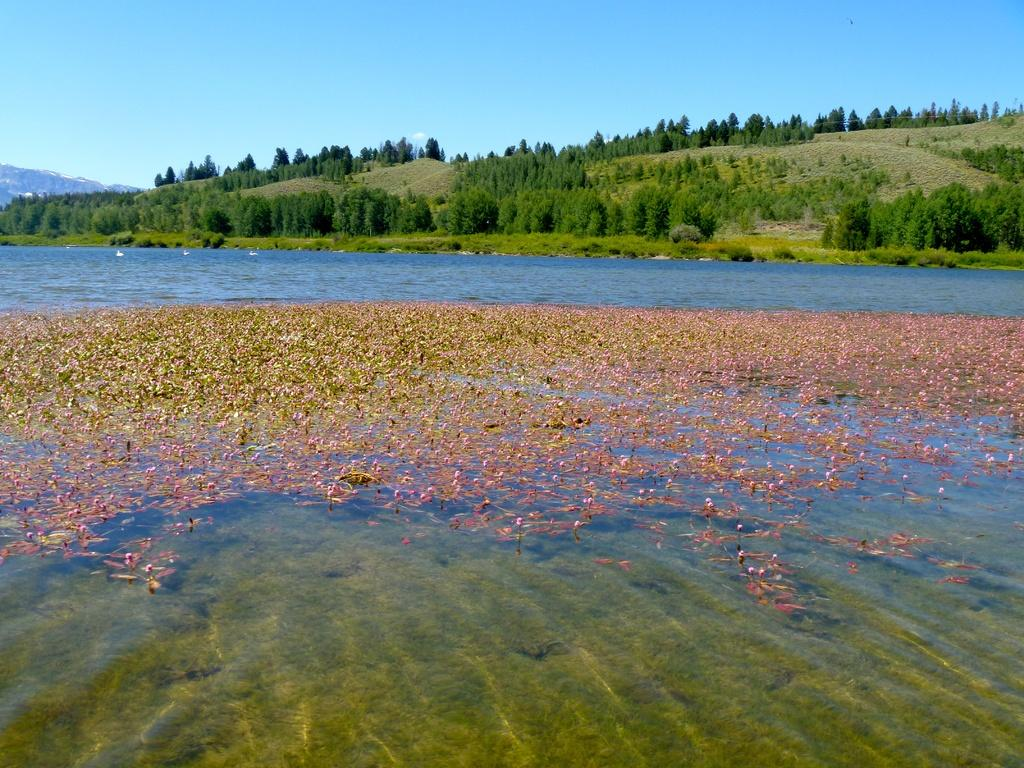What is the main feature in the center of the image? There is a lake in the center of the image. What is floating on the surface of the lake? Duckweeds are present on the water. What can be seen in the background of the image? There are trees and hills in the background of the image. What is visible above the trees and hills? The sky is visible in the background of the image. How does the lake expand its territory in the image? The lake does not expand its territory in the image; it is a static body of water. 